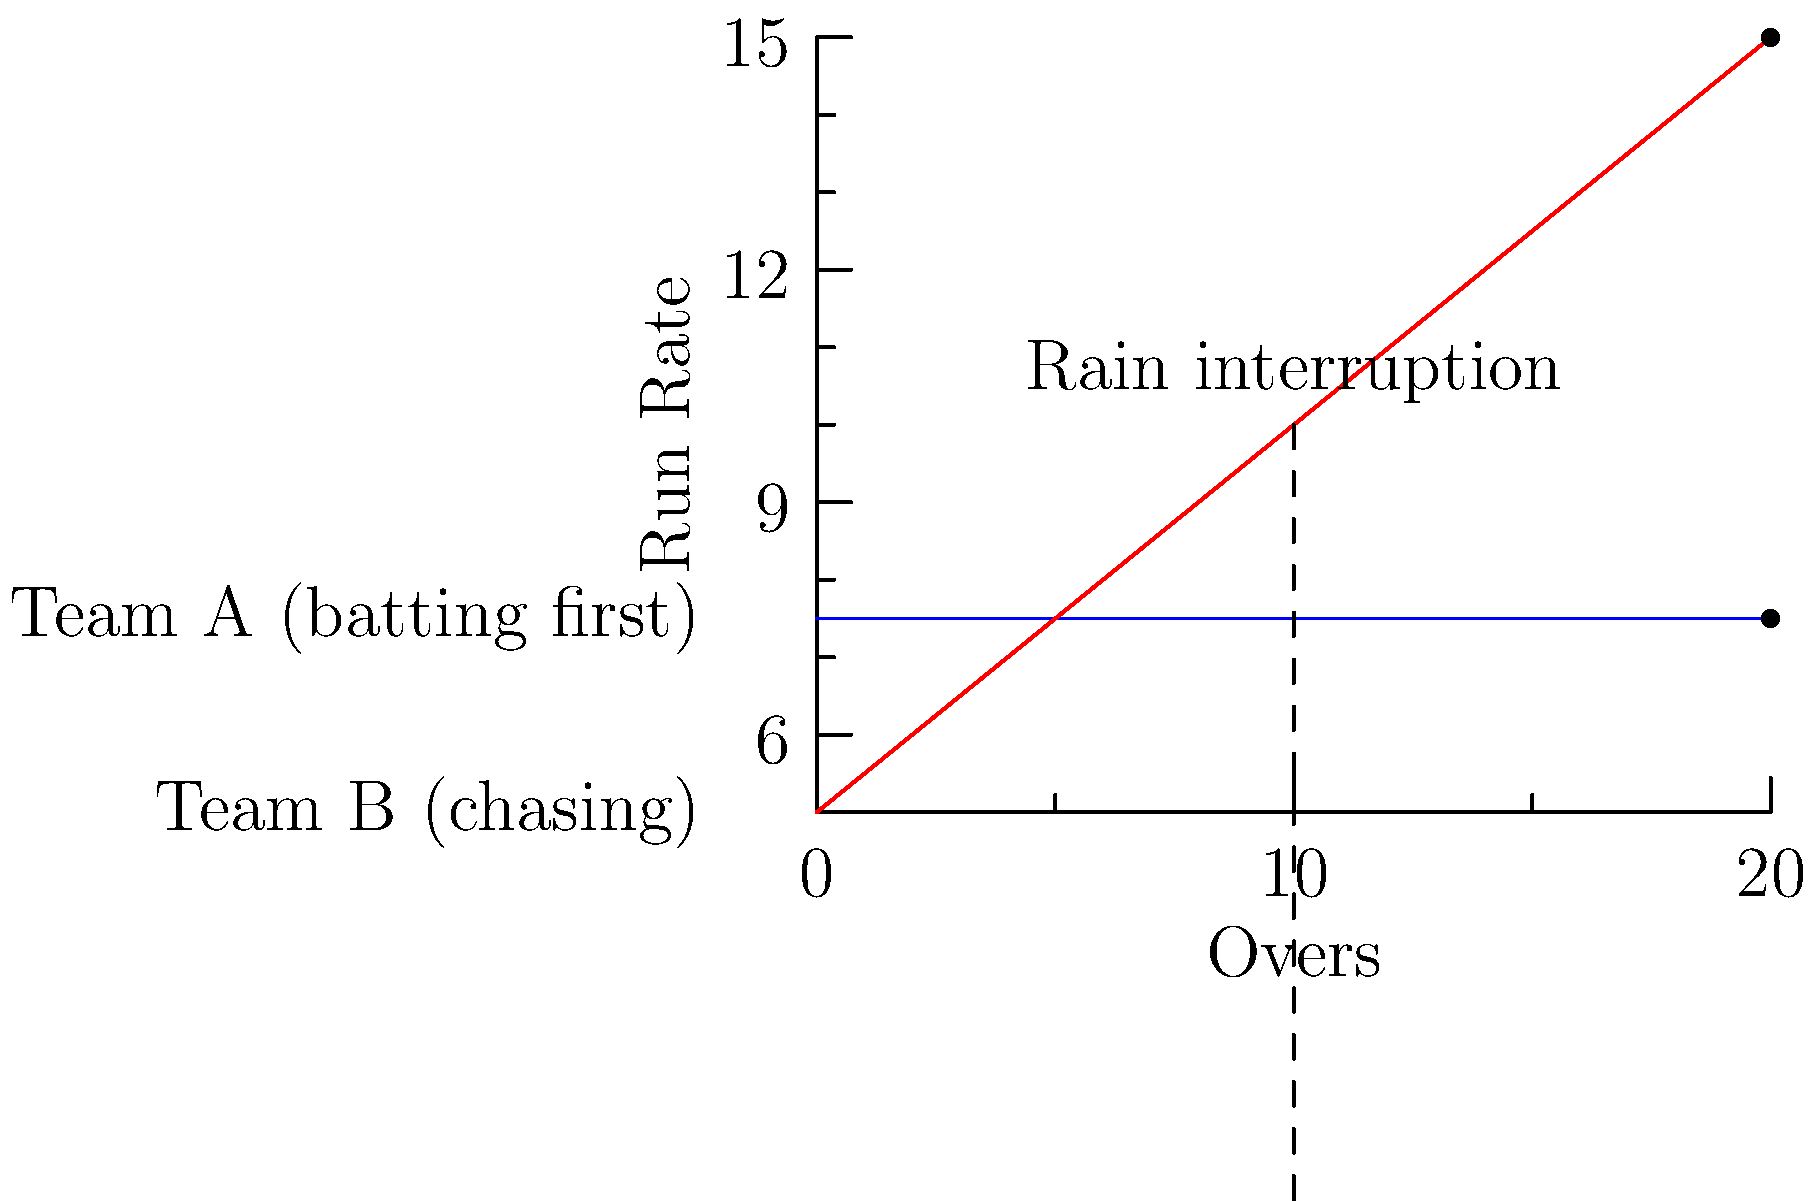In a BBL match, Team A sets a target with a run rate of 7.5 runs per over. Team B starts the chase, but rain interrupts the match after 10 overs. Using the Duckworth-Lewis-Stern (DLS) method and the given run rate graph, what would be the revised target for Team B if the match is reduced to 15 overs? To solve this problem, we need to follow these steps:

1. Understand the initial situation:
   - Team A's run rate: 7.5 runs/over
   - Original match length: 20 overs
   - Team A's total score: $7.5 \times 20 = 150$ runs

2. Analyze Team B's situation:
   - Match interrupted after 10 overs
   - Reduced to 15 overs total

3. Apply the DLS method:
   - DLS considers resources available (overs and wickets)
   - In this simplified version, we'll focus on overs only

4. Calculate the resource percentage:
   - Original resources: 20 overs (100%)
   - Remaining resources: 15 - 10 = 5 overs (25%)

5. Adjust the target:
   - Team B's expected score at 15 overs (from graph): $5 + 0.5 \times 15 = 12.5$ runs/over
   - Total expected score: $12.5 \times 15 = 187.5$ runs

6. Calculate the revised target:
   - Revised target = (Team A's score × Remaining resource %) + Team B's expected score
   - Revised target = $(150 \times 0.25) + 187.5 = 225$ runs

7. Round down to the nearest integer:
   - Final revised target: 224 runs
Answer: 224 runs 